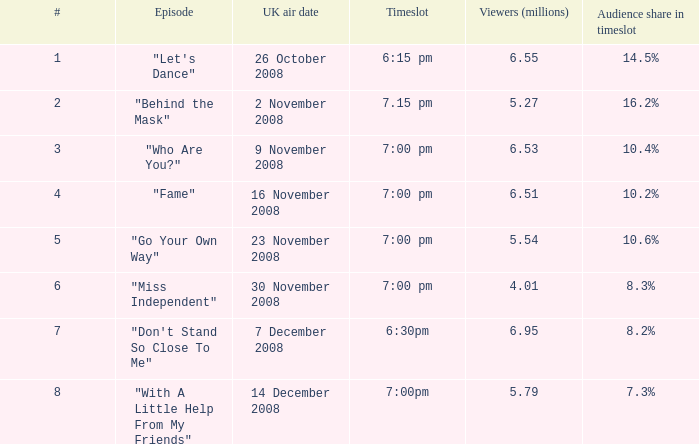Parse the table in full. {'header': ['#', 'Episode', 'UK air date', 'Timeslot', 'Viewers (millions)', 'Audience share in timeslot'], 'rows': [['1', '"Let\'s Dance"', '26 October 2008', '6:15 pm', '6.55', '14.5%'], ['2', '"Behind the Mask"', '2 November 2008', '7.15 pm', '5.27', '16.2%'], ['3', '"Who Are You?"', '9 November 2008', '7:00 pm', '6.53', '10.4%'], ['4', '"Fame"', '16 November 2008', '7:00 pm', '6.51', '10.2%'], ['5', '"Go Your Own Way"', '23 November 2008', '7:00 pm', '5.54', '10.6%'], ['6', '"Miss Independent"', '30 November 2008', '7:00 pm', '4.01', '8.3%'], ['7', '"Don\'t Stand So Close To Me"', '7 December 2008', '6:30pm', '6.95', '8.2%'], ['8', '"With A Little Help From My Friends"', '14 December 2008', '7:00pm', '5.79', '7.3%']]} Name the total number of timeslot for number 1 1.0. 